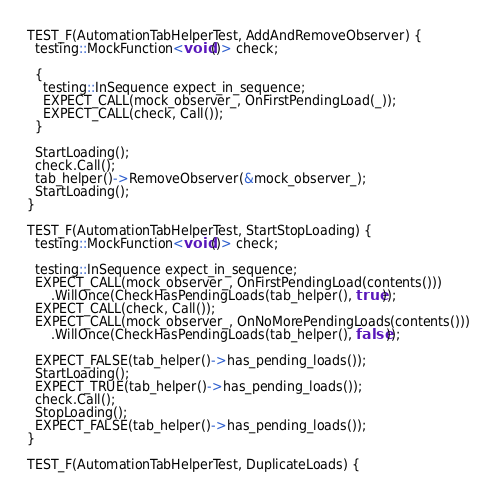Convert code to text. <code><loc_0><loc_0><loc_500><loc_500><_C++_>
TEST_F(AutomationTabHelperTest, AddAndRemoveObserver) {
  testing::MockFunction<void()> check;

  {
    testing::InSequence expect_in_sequence;
    EXPECT_CALL(mock_observer_, OnFirstPendingLoad(_));
    EXPECT_CALL(check, Call());
  }

  StartLoading();
  check.Call();
  tab_helper()->RemoveObserver(&mock_observer_);
  StartLoading();
}

TEST_F(AutomationTabHelperTest, StartStopLoading) {
  testing::MockFunction<void()> check;

  testing::InSequence expect_in_sequence;
  EXPECT_CALL(mock_observer_, OnFirstPendingLoad(contents()))
      .WillOnce(CheckHasPendingLoads(tab_helper(), true));
  EXPECT_CALL(check, Call());
  EXPECT_CALL(mock_observer_, OnNoMorePendingLoads(contents()))
      .WillOnce(CheckHasPendingLoads(tab_helper(), false));

  EXPECT_FALSE(tab_helper()->has_pending_loads());
  StartLoading();
  EXPECT_TRUE(tab_helper()->has_pending_loads());
  check.Call();
  StopLoading();
  EXPECT_FALSE(tab_helper()->has_pending_loads());
}

TEST_F(AutomationTabHelperTest, DuplicateLoads) {</code> 